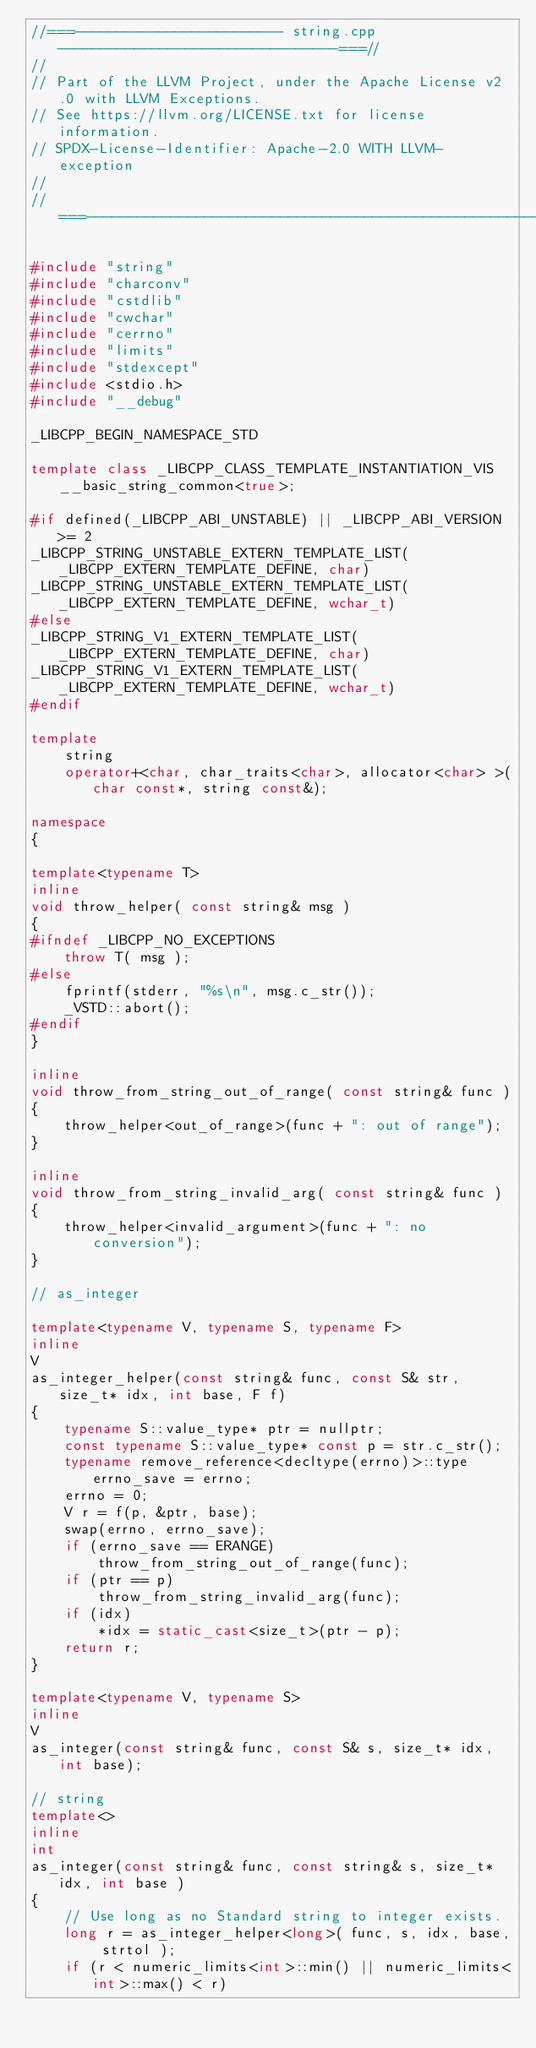<code> <loc_0><loc_0><loc_500><loc_500><_C++_>//===------------------------- string.cpp ---------------------------------===//
//
// Part of the LLVM Project, under the Apache License v2.0 with LLVM Exceptions.
// See https://llvm.org/LICENSE.txt for license information.
// SPDX-License-Identifier: Apache-2.0 WITH LLVM-exception
//
//===----------------------------------------------------------------------===//

#include "string"
#include "charconv"
#include "cstdlib"
#include "cwchar"
#include "cerrno"
#include "limits"
#include "stdexcept"
#include <stdio.h>
#include "__debug"

_LIBCPP_BEGIN_NAMESPACE_STD

template class _LIBCPP_CLASS_TEMPLATE_INSTANTIATION_VIS __basic_string_common<true>;

#if defined(_LIBCPP_ABI_UNSTABLE) || _LIBCPP_ABI_VERSION >= 2
_LIBCPP_STRING_UNSTABLE_EXTERN_TEMPLATE_LIST(_LIBCPP_EXTERN_TEMPLATE_DEFINE, char)
_LIBCPP_STRING_UNSTABLE_EXTERN_TEMPLATE_LIST(_LIBCPP_EXTERN_TEMPLATE_DEFINE, wchar_t)
#else
_LIBCPP_STRING_V1_EXTERN_TEMPLATE_LIST(_LIBCPP_EXTERN_TEMPLATE_DEFINE, char)
_LIBCPP_STRING_V1_EXTERN_TEMPLATE_LIST(_LIBCPP_EXTERN_TEMPLATE_DEFINE, wchar_t)
#endif

template
    string
    operator+<char, char_traits<char>, allocator<char> >(char const*, string const&);

namespace
{

template<typename T>
inline
void throw_helper( const string& msg )
{
#ifndef _LIBCPP_NO_EXCEPTIONS
    throw T( msg );
#else
    fprintf(stderr, "%s\n", msg.c_str());
    _VSTD::abort();
#endif
}

inline
void throw_from_string_out_of_range( const string& func )
{
    throw_helper<out_of_range>(func + ": out of range");
}

inline
void throw_from_string_invalid_arg( const string& func )
{
    throw_helper<invalid_argument>(func + ": no conversion");
}

// as_integer

template<typename V, typename S, typename F>
inline
V
as_integer_helper(const string& func, const S& str, size_t* idx, int base, F f)
{
    typename S::value_type* ptr = nullptr;
    const typename S::value_type* const p = str.c_str();
    typename remove_reference<decltype(errno)>::type errno_save = errno;
    errno = 0;
    V r = f(p, &ptr, base);
    swap(errno, errno_save);
    if (errno_save == ERANGE)
        throw_from_string_out_of_range(func);
    if (ptr == p)
        throw_from_string_invalid_arg(func);
    if (idx)
        *idx = static_cast<size_t>(ptr - p);
    return r;
}

template<typename V, typename S>
inline
V
as_integer(const string& func, const S& s, size_t* idx, int base);

// string
template<>
inline
int
as_integer(const string& func, const string& s, size_t* idx, int base )
{
    // Use long as no Standard string to integer exists.
    long r = as_integer_helper<long>( func, s, idx, base, strtol );
    if (r < numeric_limits<int>::min() || numeric_limits<int>::max() < r)</code> 